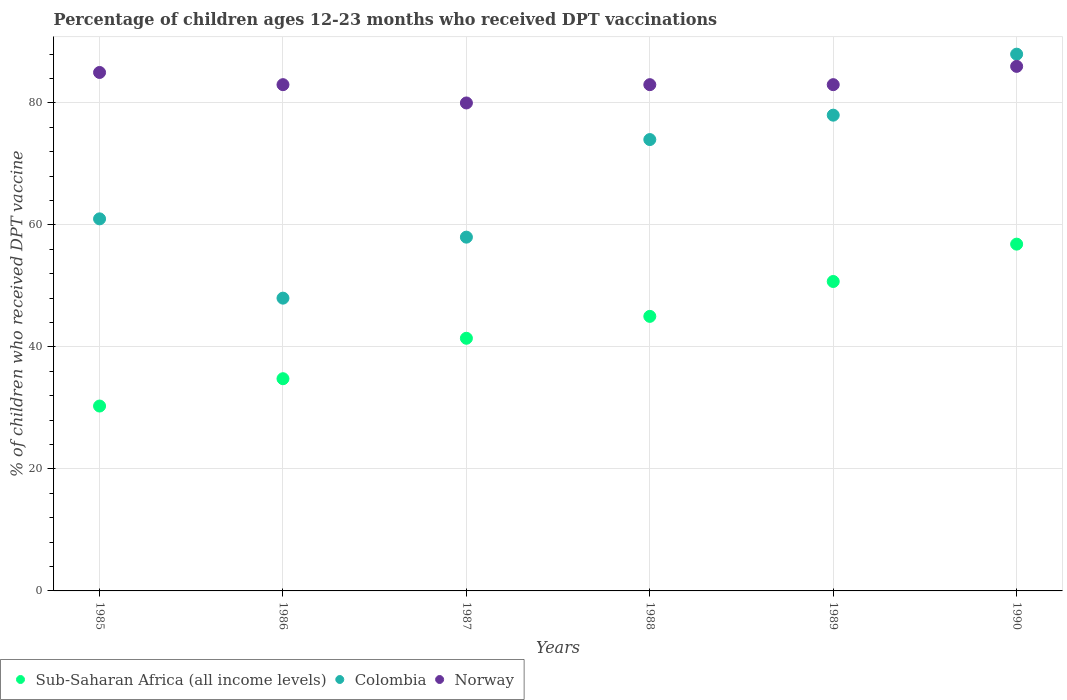How many different coloured dotlines are there?
Your answer should be very brief. 3. What is the percentage of children who received DPT vaccination in Colombia in 1985?
Ensure brevity in your answer.  61. Across all years, what is the maximum percentage of children who received DPT vaccination in Colombia?
Offer a very short reply. 88. Across all years, what is the minimum percentage of children who received DPT vaccination in Norway?
Offer a terse response. 80. In which year was the percentage of children who received DPT vaccination in Colombia maximum?
Give a very brief answer. 1990. In which year was the percentage of children who received DPT vaccination in Sub-Saharan Africa (all income levels) minimum?
Provide a succinct answer. 1985. What is the total percentage of children who received DPT vaccination in Colombia in the graph?
Your response must be concise. 407. What is the difference between the percentage of children who received DPT vaccination in Norway in 1986 and that in 1989?
Keep it short and to the point. 0. What is the difference between the percentage of children who received DPT vaccination in Sub-Saharan Africa (all income levels) in 1989 and the percentage of children who received DPT vaccination in Norway in 1986?
Offer a terse response. -32.27. What is the average percentage of children who received DPT vaccination in Sub-Saharan Africa (all income levels) per year?
Make the answer very short. 43.19. In the year 1985, what is the difference between the percentage of children who received DPT vaccination in Sub-Saharan Africa (all income levels) and percentage of children who received DPT vaccination in Colombia?
Keep it short and to the point. -30.69. In how many years, is the percentage of children who received DPT vaccination in Sub-Saharan Africa (all income levels) greater than 24 %?
Ensure brevity in your answer.  6. What is the ratio of the percentage of children who received DPT vaccination in Sub-Saharan Africa (all income levels) in 1985 to that in 1990?
Your answer should be very brief. 0.53. Is the percentage of children who received DPT vaccination in Norway in 1985 less than that in 1989?
Provide a succinct answer. No. What is the difference between the highest and the second highest percentage of children who received DPT vaccination in Colombia?
Your answer should be compact. 10. What is the difference between the highest and the lowest percentage of children who received DPT vaccination in Sub-Saharan Africa (all income levels)?
Make the answer very short. 26.54. In how many years, is the percentage of children who received DPT vaccination in Sub-Saharan Africa (all income levels) greater than the average percentage of children who received DPT vaccination in Sub-Saharan Africa (all income levels) taken over all years?
Keep it short and to the point. 3. Is the sum of the percentage of children who received DPT vaccination in Sub-Saharan Africa (all income levels) in 1987 and 1989 greater than the maximum percentage of children who received DPT vaccination in Norway across all years?
Keep it short and to the point. Yes. Is it the case that in every year, the sum of the percentage of children who received DPT vaccination in Colombia and percentage of children who received DPT vaccination in Norway  is greater than the percentage of children who received DPT vaccination in Sub-Saharan Africa (all income levels)?
Your answer should be compact. Yes. Does the percentage of children who received DPT vaccination in Colombia monotonically increase over the years?
Ensure brevity in your answer.  No. Is the percentage of children who received DPT vaccination in Sub-Saharan Africa (all income levels) strictly greater than the percentage of children who received DPT vaccination in Norway over the years?
Provide a succinct answer. No. Is the percentage of children who received DPT vaccination in Colombia strictly less than the percentage of children who received DPT vaccination in Sub-Saharan Africa (all income levels) over the years?
Provide a short and direct response. No. How many dotlines are there?
Offer a very short reply. 3. Are the values on the major ticks of Y-axis written in scientific E-notation?
Your answer should be very brief. No. Does the graph contain any zero values?
Offer a terse response. No. Does the graph contain grids?
Keep it short and to the point. Yes. Where does the legend appear in the graph?
Keep it short and to the point. Bottom left. What is the title of the graph?
Provide a short and direct response. Percentage of children ages 12-23 months who received DPT vaccinations. What is the label or title of the X-axis?
Your answer should be compact. Years. What is the label or title of the Y-axis?
Make the answer very short. % of children who received DPT vaccine. What is the % of children who received DPT vaccine in Sub-Saharan Africa (all income levels) in 1985?
Provide a short and direct response. 30.31. What is the % of children who received DPT vaccine of Norway in 1985?
Provide a succinct answer. 85. What is the % of children who received DPT vaccine in Sub-Saharan Africa (all income levels) in 1986?
Make the answer very short. 34.79. What is the % of children who received DPT vaccine of Norway in 1986?
Your answer should be very brief. 83. What is the % of children who received DPT vaccine in Sub-Saharan Africa (all income levels) in 1987?
Provide a succinct answer. 41.42. What is the % of children who received DPT vaccine of Colombia in 1987?
Your answer should be compact. 58. What is the % of children who received DPT vaccine in Sub-Saharan Africa (all income levels) in 1988?
Provide a succinct answer. 45.01. What is the % of children who received DPT vaccine in Sub-Saharan Africa (all income levels) in 1989?
Offer a terse response. 50.73. What is the % of children who received DPT vaccine in Sub-Saharan Africa (all income levels) in 1990?
Your answer should be very brief. 56.85. What is the % of children who received DPT vaccine in Colombia in 1990?
Keep it short and to the point. 88. What is the % of children who received DPT vaccine in Norway in 1990?
Keep it short and to the point. 86. Across all years, what is the maximum % of children who received DPT vaccine of Sub-Saharan Africa (all income levels)?
Provide a short and direct response. 56.85. Across all years, what is the maximum % of children who received DPT vaccine of Colombia?
Keep it short and to the point. 88. Across all years, what is the minimum % of children who received DPT vaccine in Sub-Saharan Africa (all income levels)?
Your response must be concise. 30.31. Across all years, what is the minimum % of children who received DPT vaccine of Colombia?
Make the answer very short. 48. What is the total % of children who received DPT vaccine in Sub-Saharan Africa (all income levels) in the graph?
Make the answer very short. 259.12. What is the total % of children who received DPT vaccine in Colombia in the graph?
Provide a succinct answer. 407. What is the total % of children who received DPT vaccine in Norway in the graph?
Your answer should be very brief. 500. What is the difference between the % of children who received DPT vaccine of Sub-Saharan Africa (all income levels) in 1985 and that in 1986?
Your answer should be compact. -4.48. What is the difference between the % of children who received DPT vaccine in Norway in 1985 and that in 1986?
Keep it short and to the point. 2. What is the difference between the % of children who received DPT vaccine of Sub-Saharan Africa (all income levels) in 1985 and that in 1987?
Your answer should be compact. -11.11. What is the difference between the % of children who received DPT vaccine in Colombia in 1985 and that in 1987?
Your answer should be very brief. 3. What is the difference between the % of children who received DPT vaccine in Norway in 1985 and that in 1987?
Your answer should be compact. 5. What is the difference between the % of children who received DPT vaccine in Sub-Saharan Africa (all income levels) in 1985 and that in 1988?
Keep it short and to the point. -14.7. What is the difference between the % of children who received DPT vaccine in Norway in 1985 and that in 1988?
Provide a short and direct response. 2. What is the difference between the % of children who received DPT vaccine in Sub-Saharan Africa (all income levels) in 1985 and that in 1989?
Provide a succinct answer. -20.42. What is the difference between the % of children who received DPT vaccine in Colombia in 1985 and that in 1989?
Make the answer very short. -17. What is the difference between the % of children who received DPT vaccine in Sub-Saharan Africa (all income levels) in 1985 and that in 1990?
Your response must be concise. -26.54. What is the difference between the % of children who received DPT vaccine of Norway in 1985 and that in 1990?
Ensure brevity in your answer.  -1. What is the difference between the % of children who received DPT vaccine in Sub-Saharan Africa (all income levels) in 1986 and that in 1987?
Offer a very short reply. -6.63. What is the difference between the % of children who received DPT vaccine in Colombia in 1986 and that in 1987?
Offer a terse response. -10. What is the difference between the % of children who received DPT vaccine of Norway in 1986 and that in 1987?
Your answer should be very brief. 3. What is the difference between the % of children who received DPT vaccine of Sub-Saharan Africa (all income levels) in 1986 and that in 1988?
Provide a succinct answer. -10.22. What is the difference between the % of children who received DPT vaccine in Colombia in 1986 and that in 1988?
Offer a very short reply. -26. What is the difference between the % of children who received DPT vaccine of Sub-Saharan Africa (all income levels) in 1986 and that in 1989?
Provide a short and direct response. -15.94. What is the difference between the % of children who received DPT vaccine of Sub-Saharan Africa (all income levels) in 1986 and that in 1990?
Give a very brief answer. -22.06. What is the difference between the % of children who received DPT vaccine of Colombia in 1986 and that in 1990?
Provide a short and direct response. -40. What is the difference between the % of children who received DPT vaccine of Sub-Saharan Africa (all income levels) in 1987 and that in 1988?
Your answer should be very brief. -3.59. What is the difference between the % of children who received DPT vaccine in Colombia in 1987 and that in 1988?
Your answer should be compact. -16. What is the difference between the % of children who received DPT vaccine in Norway in 1987 and that in 1988?
Offer a terse response. -3. What is the difference between the % of children who received DPT vaccine in Sub-Saharan Africa (all income levels) in 1987 and that in 1989?
Provide a succinct answer. -9.31. What is the difference between the % of children who received DPT vaccine of Colombia in 1987 and that in 1989?
Ensure brevity in your answer.  -20. What is the difference between the % of children who received DPT vaccine in Norway in 1987 and that in 1989?
Your answer should be very brief. -3. What is the difference between the % of children who received DPT vaccine in Sub-Saharan Africa (all income levels) in 1987 and that in 1990?
Ensure brevity in your answer.  -15.43. What is the difference between the % of children who received DPT vaccine of Colombia in 1987 and that in 1990?
Your answer should be very brief. -30. What is the difference between the % of children who received DPT vaccine in Sub-Saharan Africa (all income levels) in 1988 and that in 1989?
Give a very brief answer. -5.72. What is the difference between the % of children who received DPT vaccine in Sub-Saharan Africa (all income levels) in 1988 and that in 1990?
Ensure brevity in your answer.  -11.84. What is the difference between the % of children who received DPT vaccine of Norway in 1988 and that in 1990?
Provide a succinct answer. -3. What is the difference between the % of children who received DPT vaccine in Sub-Saharan Africa (all income levels) in 1989 and that in 1990?
Provide a succinct answer. -6.12. What is the difference between the % of children who received DPT vaccine of Sub-Saharan Africa (all income levels) in 1985 and the % of children who received DPT vaccine of Colombia in 1986?
Make the answer very short. -17.69. What is the difference between the % of children who received DPT vaccine in Sub-Saharan Africa (all income levels) in 1985 and the % of children who received DPT vaccine in Norway in 1986?
Ensure brevity in your answer.  -52.69. What is the difference between the % of children who received DPT vaccine in Colombia in 1985 and the % of children who received DPT vaccine in Norway in 1986?
Offer a very short reply. -22. What is the difference between the % of children who received DPT vaccine in Sub-Saharan Africa (all income levels) in 1985 and the % of children who received DPT vaccine in Colombia in 1987?
Provide a short and direct response. -27.69. What is the difference between the % of children who received DPT vaccine in Sub-Saharan Africa (all income levels) in 1985 and the % of children who received DPT vaccine in Norway in 1987?
Offer a very short reply. -49.69. What is the difference between the % of children who received DPT vaccine in Colombia in 1985 and the % of children who received DPT vaccine in Norway in 1987?
Provide a succinct answer. -19. What is the difference between the % of children who received DPT vaccine in Sub-Saharan Africa (all income levels) in 1985 and the % of children who received DPT vaccine in Colombia in 1988?
Make the answer very short. -43.69. What is the difference between the % of children who received DPT vaccine in Sub-Saharan Africa (all income levels) in 1985 and the % of children who received DPT vaccine in Norway in 1988?
Give a very brief answer. -52.69. What is the difference between the % of children who received DPT vaccine in Colombia in 1985 and the % of children who received DPT vaccine in Norway in 1988?
Provide a short and direct response. -22. What is the difference between the % of children who received DPT vaccine of Sub-Saharan Africa (all income levels) in 1985 and the % of children who received DPT vaccine of Colombia in 1989?
Keep it short and to the point. -47.69. What is the difference between the % of children who received DPT vaccine of Sub-Saharan Africa (all income levels) in 1985 and the % of children who received DPT vaccine of Norway in 1989?
Offer a terse response. -52.69. What is the difference between the % of children who received DPT vaccine in Colombia in 1985 and the % of children who received DPT vaccine in Norway in 1989?
Your response must be concise. -22. What is the difference between the % of children who received DPT vaccine in Sub-Saharan Africa (all income levels) in 1985 and the % of children who received DPT vaccine in Colombia in 1990?
Make the answer very short. -57.69. What is the difference between the % of children who received DPT vaccine of Sub-Saharan Africa (all income levels) in 1985 and the % of children who received DPT vaccine of Norway in 1990?
Ensure brevity in your answer.  -55.69. What is the difference between the % of children who received DPT vaccine in Sub-Saharan Africa (all income levels) in 1986 and the % of children who received DPT vaccine in Colombia in 1987?
Offer a very short reply. -23.21. What is the difference between the % of children who received DPT vaccine of Sub-Saharan Africa (all income levels) in 1986 and the % of children who received DPT vaccine of Norway in 1987?
Your answer should be compact. -45.21. What is the difference between the % of children who received DPT vaccine in Colombia in 1986 and the % of children who received DPT vaccine in Norway in 1987?
Give a very brief answer. -32. What is the difference between the % of children who received DPT vaccine of Sub-Saharan Africa (all income levels) in 1986 and the % of children who received DPT vaccine of Colombia in 1988?
Your answer should be very brief. -39.21. What is the difference between the % of children who received DPT vaccine of Sub-Saharan Africa (all income levels) in 1986 and the % of children who received DPT vaccine of Norway in 1988?
Offer a very short reply. -48.21. What is the difference between the % of children who received DPT vaccine in Colombia in 1986 and the % of children who received DPT vaccine in Norway in 1988?
Provide a short and direct response. -35. What is the difference between the % of children who received DPT vaccine in Sub-Saharan Africa (all income levels) in 1986 and the % of children who received DPT vaccine in Colombia in 1989?
Offer a terse response. -43.21. What is the difference between the % of children who received DPT vaccine in Sub-Saharan Africa (all income levels) in 1986 and the % of children who received DPT vaccine in Norway in 1989?
Offer a very short reply. -48.21. What is the difference between the % of children who received DPT vaccine in Colombia in 1986 and the % of children who received DPT vaccine in Norway in 1989?
Offer a terse response. -35. What is the difference between the % of children who received DPT vaccine of Sub-Saharan Africa (all income levels) in 1986 and the % of children who received DPT vaccine of Colombia in 1990?
Provide a succinct answer. -53.21. What is the difference between the % of children who received DPT vaccine in Sub-Saharan Africa (all income levels) in 1986 and the % of children who received DPT vaccine in Norway in 1990?
Your answer should be compact. -51.21. What is the difference between the % of children who received DPT vaccine of Colombia in 1986 and the % of children who received DPT vaccine of Norway in 1990?
Ensure brevity in your answer.  -38. What is the difference between the % of children who received DPT vaccine of Sub-Saharan Africa (all income levels) in 1987 and the % of children who received DPT vaccine of Colombia in 1988?
Make the answer very short. -32.58. What is the difference between the % of children who received DPT vaccine in Sub-Saharan Africa (all income levels) in 1987 and the % of children who received DPT vaccine in Norway in 1988?
Provide a succinct answer. -41.58. What is the difference between the % of children who received DPT vaccine in Sub-Saharan Africa (all income levels) in 1987 and the % of children who received DPT vaccine in Colombia in 1989?
Provide a short and direct response. -36.58. What is the difference between the % of children who received DPT vaccine of Sub-Saharan Africa (all income levels) in 1987 and the % of children who received DPT vaccine of Norway in 1989?
Offer a terse response. -41.58. What is the difference between the % of children who received DPT vaccine in Colombia in 1987 and the % of children who received DPT vaccine in Norway in 1989?
Offer a very short reply. -25. What is the difference between the % of children who received DPT vaccine of Sub-Saharan Africa (all income levels) in 1987 and the % of children who received DPT vaccine of Colombia in 1990?
Ensure brevity in your answer.  -46.58. What is the difference between the % of children who received DPT vaccine in Sub-Saharan Africa (all income levels) in 1987 and the % of children who received DPT vaccine in Norway in 1990?
Your answer should be very brief. -44.58. What is the difference between the % of children who received DPT vaccine in Sub-Saharan Africa (all income levels) in 1988 and the % of children who received DPT vaccine in Colombia in 1989?
Provide a short and direct response. -32.99. What is the difference between the % of children who received DPT vaccine in Sub-Saharan Africa (all income levels) in 1988 and the % of children who received DPT vaccine in Norway in 1989?
Give a very brief answer. -37.99. What is the difference between the % of children who received DPT vaccine of Colombia in 1988 and the % of children who received DPT vaccine of Norway in 1989?
Your response must be concise. -9. What is the difference between the % of children who received DPT vaccine of Sub-Saharan Africa (all income levels) in 1988 and the % of children who received DPT vaccine of Colombia in 1990?
Offer a very short reply. -42.99. What is the difference between the % of children who received DPT vaccine of Sub-Saharan Africa (all income levels) in 1988 and the % of children who received DPT vaccine of Norway in 1990?
Keep it short and to the point. -40.99. What is the difference between the % of children who received DPT vaccine of Sub-Saharan Africa (all income levels) in 1989 and the % of children who received DPT vaccine of Colombia in 1990?
Provide a succinct answer. -37.27. What is the difference between the % of children who received DPT vaccine of Sub-Saharan Africa (all income levels) in 1989 and the % of children who received DPT vaccine of Norway in 1990?
Keep it short and to the point. -35.27. What is the difference between the % of children who received DPT vaccine of Colombia in 1989 and the % of children who received DPT vaccine of Norway in 1990?
Offer a terse response. -8. What is the average % of children who received DPT vaccine in Sub-Saharan Africa (all income levels) per year?
Your response must be concise. 43.19. What is the average % of children who received DPT vaccine in Colombia per year?
Your response must be concise. 67.83. What is the average % of children who received DPT vaccine in Norway per year?
Your response must be concise. 83.33. In the year 1985, what is the difference between the % of children who received DPT vaccine in Sub-Saharan Africa (all income levels) and % of children who received DPT vaccine in Colombia?
Make the answer very short. -30.69. In the year 1985, what is the difference between the % of children who received DPT vaccine in Sub-Saharan Africa (all income levels) and % of children who received DPT vaccine in Norway?
Offer a very short reply. -54.69. In the year 1985, what is the difference between the % of children who received DPT vaccine of Colombia and % of children who received DPT vaccine of Norway?
Your response must be concise. -24. In the year 1986, what is the difference between the % of children who received DPT vaccine in Sub-Saharan Africa (all income levels) and % of children who received DPT vaccine in Colombia?
Keep it short and to the point. -13.21. In the year 1986, what is the difference between the % of children who received DPT vaccine in Sub-Saharan Africa (all income levels) and % of children who received DPT vaccine in Norway?
Give a very brief answer. -48.21. In the year 1986, what is the difference between the % of children who received DPT vaccine in Colombia and % of children who received DPT vaccine in Norway?
Make the answer very short. -35. In the year 1987, what is the difference between the % of children who received DPT vaccine in Sub-Saharan Africa (all income levels) and % of children who received DPT vaccine in Colombia?
Keep it short and to the point. -16.58. In the year 1987, what is the difference between the % of children who received DPT vaccine of Sub-Saharan Africa (all income levels) and % of children who received DPT vaccine of Norway?
Offer a very short reply. -38.58. In the year 1987, what is the difference between the % of children who received DPT vaccine of Colombia and % of children who received DPT vaccine of Norway?
Make the answer very short. -22. In the year 1988, what is the difference between the % of children who received DPT vaccine of Sub-Saharan Africa (all income levels) and % of children who received DPT vaccine of Colombia?
Offer a very short reply. -28.99. In the year 1988, what is the difference between the % of children who received DPT vaccine in Sub-Saharan Africa (all income levels) and % of children who received DPT vaccine in Norway?
Provide a short and direct response. -37.99. In the year 1988, what is the difference between the % of children who received DPT vaccine in Colombia and % of children who received DPT vaccine in Norway?
Provide a short and direct response. -9. In the year 1989, what is the difference between the % of children who received DPT vaccine of Sub-Saharan Africa (all income levels) and % of children who received DPT vaccine of Colombia?
Offer a very short reply. -27.27. In the year 1989, what is the difference between the % of children who received DPT vaccine in Sub-Saharan Africa (all income levels) and % of children who received DPT vaccine in Norway?
Provide a short and direct response. -32.27. In the year 1990, what is the difference between the % of children who received DPT vaccine in Sub-Saharan Africa (all income levels) and % of children who received DPT vaccine in Colombia?
Your answer should be very brief. -31.15. In the year 1990, what is the difference between the % of children who received DPT vaccine in Sub-Saharan Africa (all income levels) and % of children who received DPT vaccine in Norway?
Your answer should be very brief. -29.15. What is the ratio of the % of children who received DPT vaccine in Sub-Saharan Africa (all income levels) in 1985 to that in 1986?
Keep it short and to the point. 0.87. What is the ratio of the % of children who received DPT vaccine in Colombia in 1985 to that in 1986?
Make the answer very short. 1.27. What is the ratio of the % of children who received DPT vaccine of Norway in 1985 to that in 1986?
Your answer should be compact. 1.02. What is the ratio of the % of children who received DPT vaccine in Sub-Saharan Africa (all income levels) in 1985 to that in 1987?
Your answer should be compact. 0.73. What is the ratio of the % of children who received DPT vaccine in Colombia in 1985 to that in 1987?
Ensure brevity in your answer.  1.05. What is the ratio of the % of children who received DPT vaccine in Norway in 1985 to that in 1987?
Your answer should be very brief. 1.06. What is the ratio of the % of children who received DPT vaccine in Sub-Saharan Africa (all income levels) in 1985 to that in 1988?
Offer a very short reply. 0.67. What is the ratio of the % of children who received DPT vaccine in Colombia in 1985 to that in 1988?
Your answer should be compact. 0.82. What is the ratio of the % of children who received DPT vaccine in Norway in 1985 to that in 1988?
Keep it short and to the point. 1.02. What is the ratio of the % of children who received DPT vaccine in Sub-Saharan Africa (all income levels) in 1985 to that in 1989?
Offer a terse response. 0.6. What is the ratio of the % of children who received DPT vaccine of Colombia in 1985 to that in 1989?
Offer a very short reply. 0.78. What is the ratio of the % of children who received DPT vaccine in Norway in 1985 to that in 1989?
Provide a short and direct response. 1.02. What is the ratio of the % of children who received DPT vaccine in Sub-Saharan Africa (all income levels) in 1985 to that in 1990?
Keep it short and to the point. 0.53. What is the ratio of the % of children who received DPT vaccine of Colombia in 1985 to that in 1990?
Offer a very short reply. 0.69. What is the ratio of the % of children who received DPT vaccine in Norway in 1985 to that in 1990?
Make the answer very short. 0.99. What is the ratio of the % of children who received DPT vaccine of Sub-Saharan Africa (all income levels) in 1986 to that in 1987?
Your answer should be compact. 0.84. What is the ratio of the % of children who received DPT vaccine in Colombia in 1986 to that in 1987?
Make the answer very short. 0.83. What is the ratio of the % of children who received DPT vaccine of Norway in 1986 to that in 1987?
Provide a short and direct response. 1.04. What is the ratio of the % of children who received DPT vaccine in Sub-Saharan Africa (all income levels) in 1986 to that in 1988?
Give a very brief answer. 0.77. What is the ratio of the % of children who received DPT vaccine in Colombia in 1986 to that in 1988?
Provide a succinct answer. 0.65. What is the ratio of the % of children who received DPT vaccine of Sub-Saharan Africa (all income levels) in 1986 to that in 1989?
Offer a terse response. 0.69. What is the ratio of the % of children who received DPT vaccine of Colombia in 1986 to that in 1989?
Your response must be concise. 0.62. What is the ratio of the % of children who received DPT vaccine in Sub-Saharan Africa (all income levels) in 1986 to that in 1990?
Provide a succinct answer. 0.61. What is the ratio of the % of children who received DPT vaccine of Colombia in 1986 to that in 1990?
Ensure brevity in your answer.  0.55. What is the ratio of the % of children who received DPT vaccine of Norway in 1986 to that in 1990?
Offer a terse response. 0.97. What is the ratio of the % of children who received DPT vaccine of Sub-Saharan Africa (all income levels) in 1987 to that in 1988?
Give a very brief answer. 0.92. What is the ratio of the % of children who received DPT vaccine of Colombia in 1987 to that in 1988?
Make the answer very short. 0.78. What is the ratio of the % of children who received DPT vaccine in Norway in 1987 to that in 1988?
Give a very brief answer. 0.96. What is the ratio of the % of children who received DPT vaccine in Sub-Saharan Africa (all income levels) in 1987 to that in 1989?
Your response must be concise. 0.82. What is the ratio of the % of children who received DPT vaccine of Colombia in 1987 to that in 1989?
Give a very brief answer. 0.74. What is the ratio of the % of children who received DPT vaccine in Norway in 1987 to that in 1989?
Your response must be concise. 0.96. What is the ratio of the % of children who received DPT vaccine in Sub-Saharan Africa (all income levels) in 1987 to that in 1990?
Make the answer very short. 0.73. What is the ratio of the % of children who received DPT vaccine in Colombia in 1987 to that in 1990?
Provide a succinct answer. 0.66. What is the ratio of the % of children who received DPT vaccine of Norway in 1987 to that in 1990?
Make the answer very short. 0.93. What is the ratio of the % of children who received DPT vaccine of Sub-Saharan Africa (all income levels) in 1988 to that in 1989?
Provide a short and direct response. 0.89. What is the ratio of the % of children who received DPT vaccine of Colombia in 1988 to that in 1989?
Keep it short and to the point. 0.95. What is the ratio of the % of children who received DPT vaccine in Norway in 1988 to that in 1989?
Keep it short and to the point. 1. What is the ratio of the % of children who received DPT vaccine of Sub-Saharan Africa (all income levels) in 1988 to that in 1990?
Provide a succinct answer. 0.79. What is the ratio of the % of children who received DPT vaccine of Colombia in 1988 to that in 1990?
Your response must be concise. 0.84. What is the ratio of the % of children who received DPT vaccine in Norway in 1988 to that in 1990?
Offer a very short reply. 0.97. What is the ratio of the % of children who received DPT vaccine in Sub-Saharan Africa (all income levels) in 1989 to that in 1990?
Provide a short and direct response. 0.89. What is the ratio of the % of children who received DPT vaccine of Colombia in 1989 to that in 1990?
Offer a terse response. 0.89. What is the ratio of the % of children who received DPT vaccine in Norway in 1989 to that in 1990?
Your answer should be compact. 0.97. What is the difference between the highest and the second highest % of children who received DPT vaccine in Sub-Saharan Africa (all income levels)?
Ensure brevity in your answer.  6.12. What is the difference between the highest and the second highest % of children who received DPT vaccine in Colombia?
Offer a very short reply. 10. What is the difference between the highest and the lowest % of children who received DPT vaccine of Sub-Saharan Africa (all income levels)?
Give a very brief answer. 26.54. What is the difference between the highest and the lowest % of children who received DPT vaccine of Colombia?
Ensure brevity in your answer.  40. What is the difference between the highest and the lowest % of children who received DPT vaccine of Norway?
Make the answer very short. 6. 